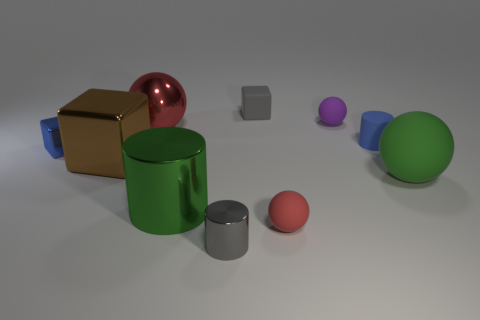What shape is the red object that is behind the cylinder that is on the left side of the tiny metallic object that is in front of the green matte ball?
Provide a short and direct response. Sphere. Do the purple ball and the blue thing to the left of the gray metallic cylinder have the same size?
Give a very brief answer. Yes. Are there any blocks that have the same size as the blue cylinder?
Your answer should be very brief. Yes. How many other things are there of the same material as the small red ball?
Your answer should be compact. 4. There is a matte object that is both behind the small matte cylinder and in front of the gray matte block; what is its color?
Offer a terse response. Purple. Do the block right of the large red metal sphere and the big ball that is behind the big rubber sphere have the same material?
Make the answer very short. No. Is the size of the block to the right of the green shiny cylinder the same as the red metallic object?
Your response must be concise. No. Does the tiny metal cylinder have the same color as the tiny block that is behind the large red thing?
Provide a succinct answer. Yes. What is the shape of the tiny matte object that is the same color as the small shiny block?
Your answer should be compact. Cylinder. There is a brown shiny thing; what shape is it?
Offer a very short reply. Cube. 